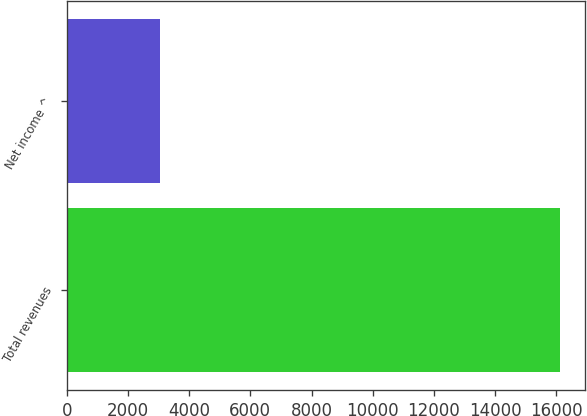<chart> <loc_0><loc_0><loc_500><loc_500><bar_chart><fcel>Total revenues<fcel>Net income ^<nl><fcel>16136<fcel>3036<nl></chart> 